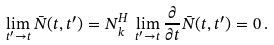Convert formula to latex. <formula><loc_0><loc_0><loc_500><loc_500>\lim _ { t ^ { \prime } \rightarrow t } \bar { N } ( t , t ^ { \prime } ) = N ^ { H } _ { k } \, \lim _ { t ^ { \prime } \rightarrow t } \frac { \partial } { \partial t } \bar { N } ( t , t ^ { \prime } ) = 0 \, .</formula> 